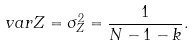Convert formula to latex. <formula><loc_0><loc_0><loc_500><loc_500>v a r Z = \sigma _ { Z } ^ { 2 } = \frac { 1 } { N - 1 - k } .</formula> 